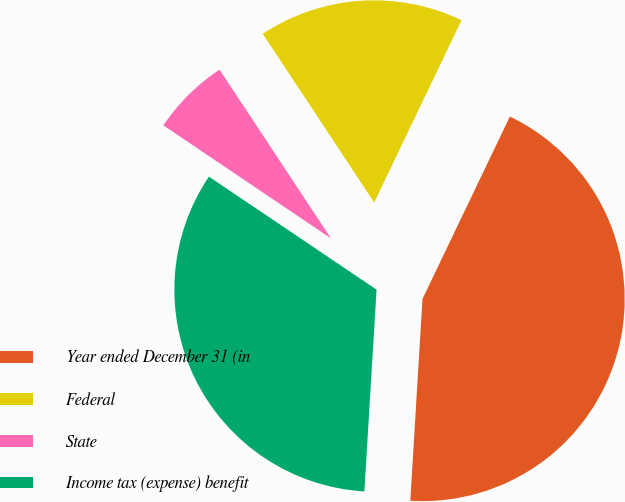Convert chart to OTSL. <chart><loc_0><loc_0><loc_500><loc_500><pie_chart><fcel>Year ended December 31 (in<fcel>Federal<fcel>State<fcel>Income tax (expense) benefit<nl><fcel>43.85%<fcel>16.4%<fcel>6.27%<fcel>33.48%<nl></chart> 